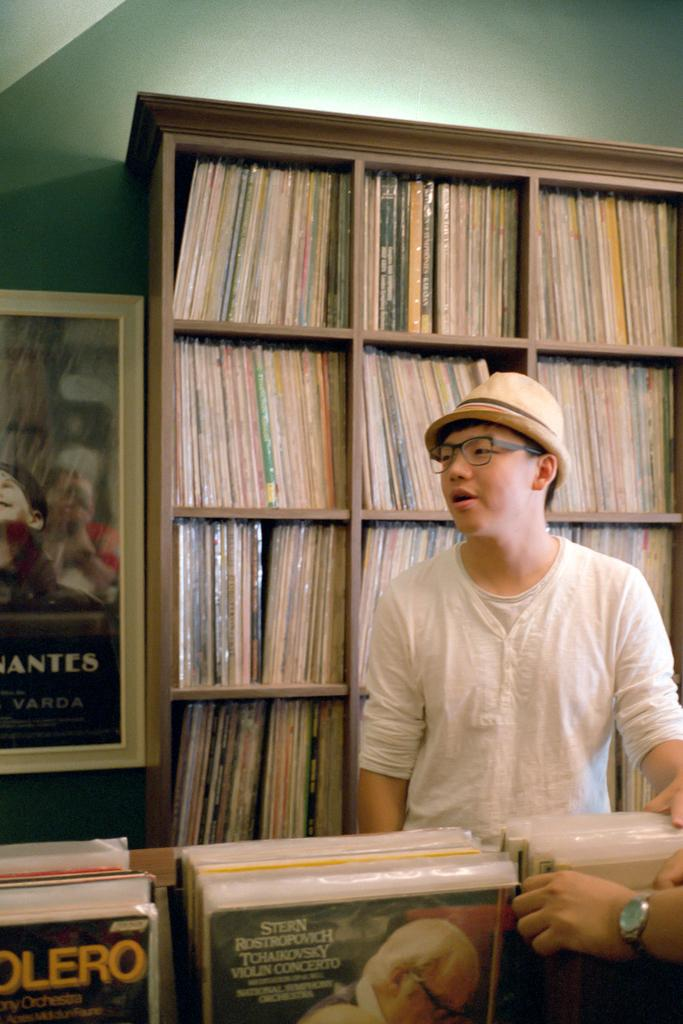<image>
Describe the image concisely. Man wearing a hat sitting behind an album with the artist "Tchaikovsky". 